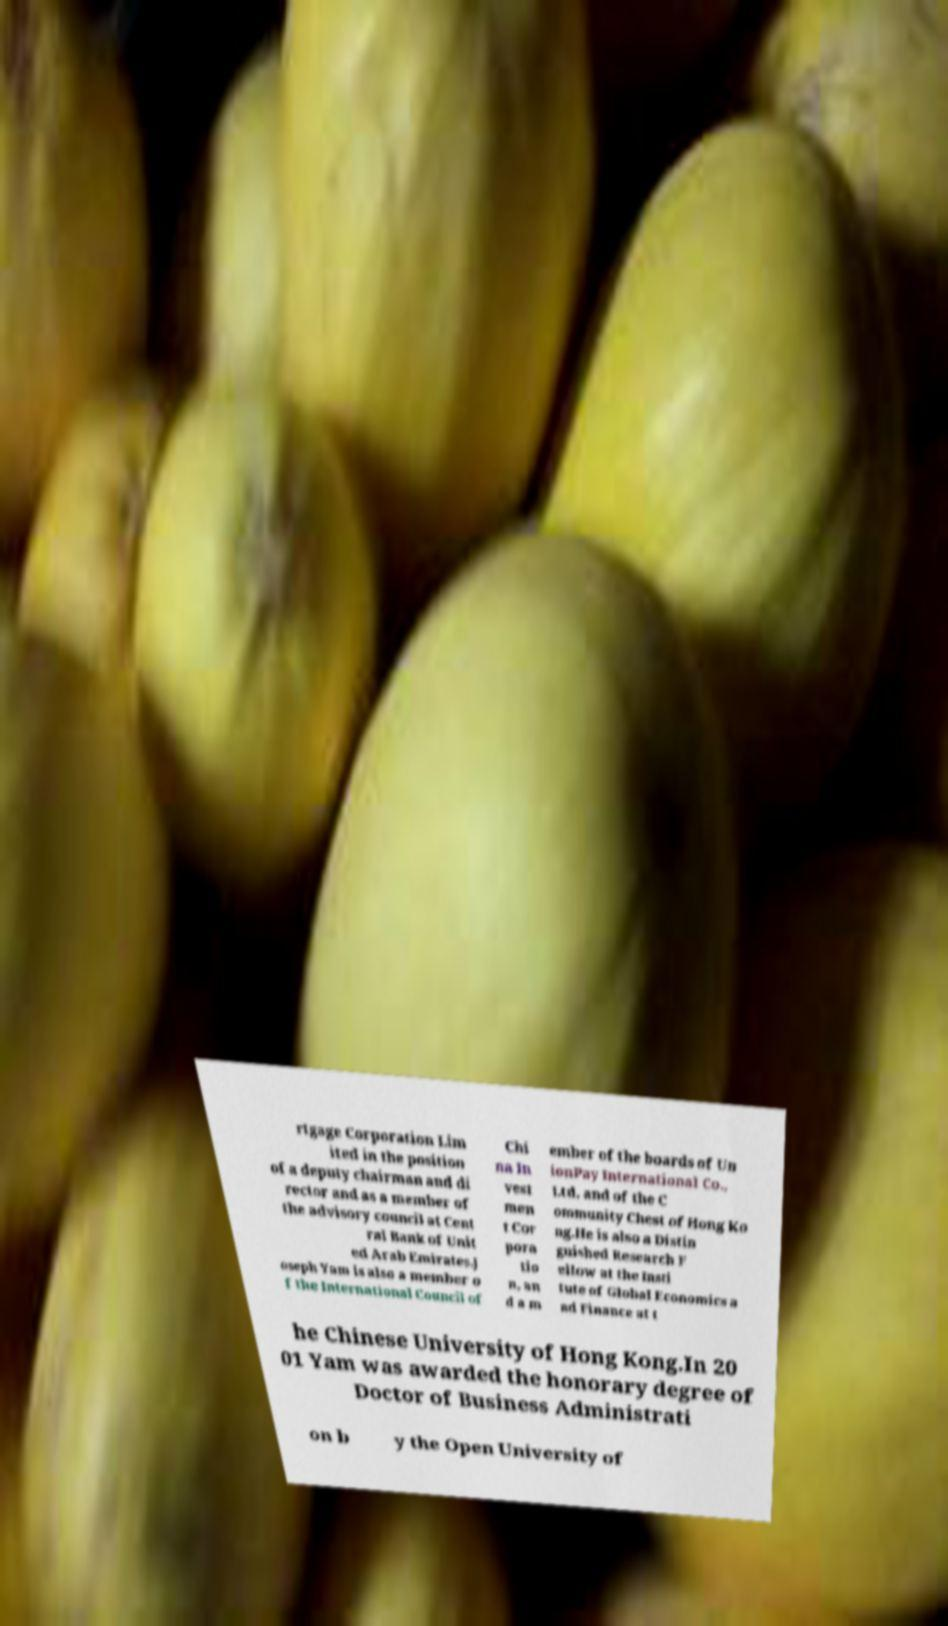I need the written content from this picture converted into text. Can you do that? rtgage Corporation Lim ited in the position of a deputy chairman and di rector and as a member of the advisory council at Cent ral Bank of Unit ed Arab Emirates.J oseph Yam is also a member o f the International Council of Chi na In vest men t Cor pora tio n, an d a m ember of the boards of Un ionPay International Co., Ltd. and of the C ommunity Chest of Hong Ko ng.He is also a Distin guished Research F ellow at the Insti tute of Global Economics a nd Finance at t he Chinese University of Hong Kong.In 20 01 Yam was awarded the honorary degree of Doctor of Business Administrati on b y the Open University of 